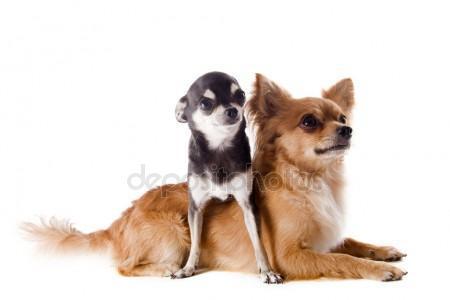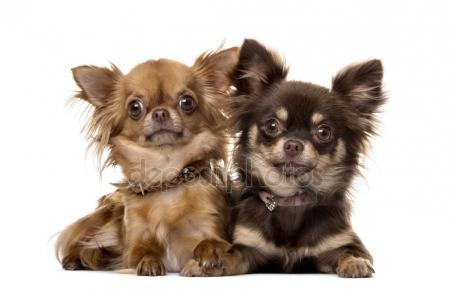The first image is the image on the left, the second image is the image on the right. Assess this claim about the two images: "Images show a total of four dogs, and all dogs are sitting upright.". Correct or not? Answer yes or no. No. The first image is the image on the left, the second image is the image on the right. Given the left and right images, does the statement "One of the images shows a pair of dogs with the white and gray dog holding a paw up." hold true? Answer yes or no. No. 